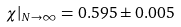<formula> <loc_0><loc_0><loc_500><loc_500>\chi | _ { N \to \infty } = 0 . 5 9 5 \pm 0 . 0 0 5</formula> 